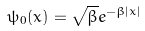<formula> <loc_0><loc_0><loc_500><loc_500>\psi _ { 0 } ( x ) = \sqrt { \beta } e ^ { - \beta | x | }</formula> 